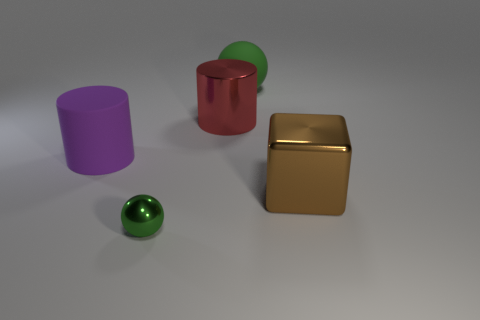How many objects are there in this image, and can you describe their colors and finishes? There are four objects in the image. Starting from the left, there is a matte purple cylinder, followed by a glossy red cylinder with a green top, resembling a canister. Next, there's a glossy gold cube, and finally, in front of all the others is a small, glossy green sphere. 